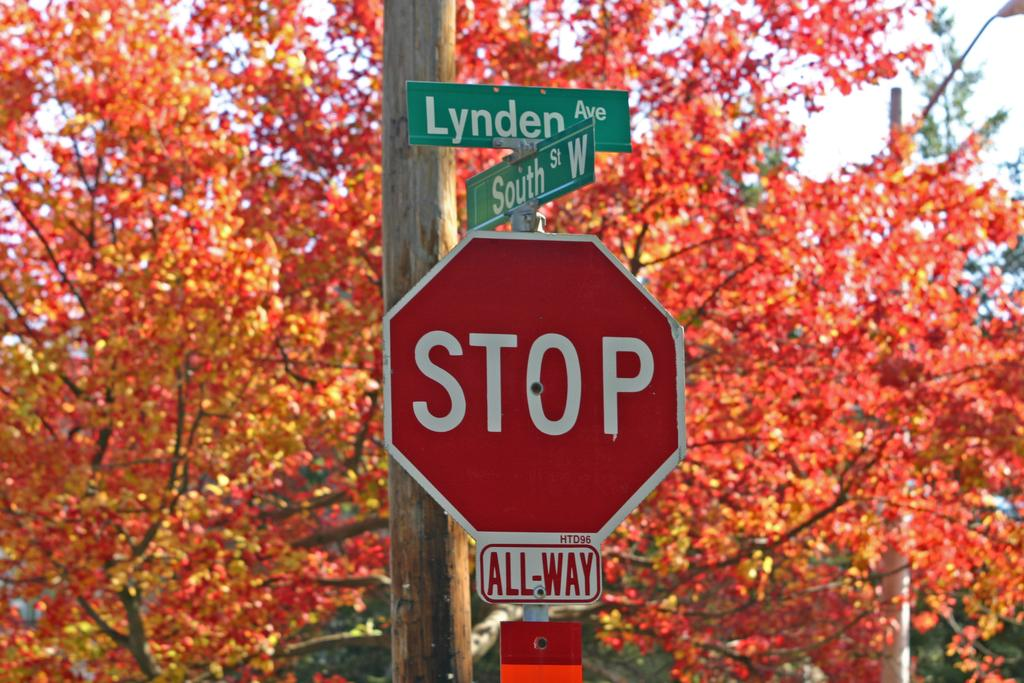<image>
Render a clear and concise summary of the photo. A red sign that says Stop is beneath two street signs which read Lynden Ave and South St W. 